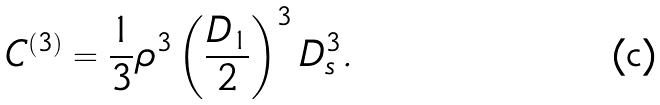Convert formula to latex. <formula><loc_0><loc_0><loc_500><loc_500>C ^ { ( 3 ) } = \frac { 1 } { 3 } \rho ^ { 3 } \left ( \frac { D _ { 1 } } { 2 } \right ) ^ { 3 } D _ { s } ^ { 3 } .</formula> 